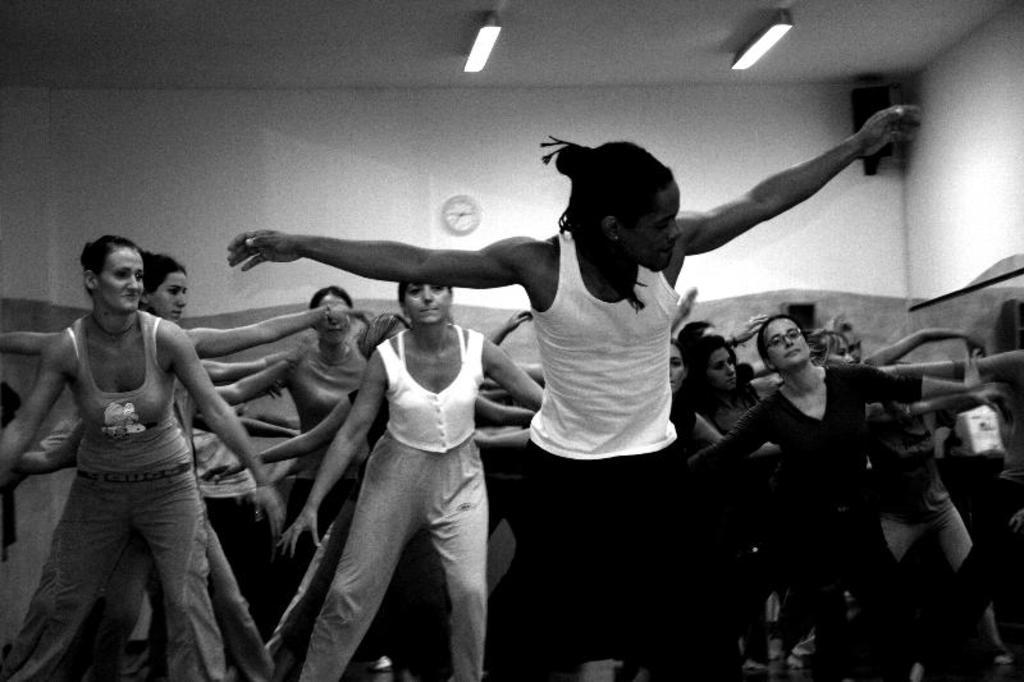What can be seen in the image involving a group of people? There is a group of people in the image. What is located at the top of the image? Lights, a clock, and a speaker are present at the top of the image. What is the color scheme of the image? The image is in black and white. How many strangers are present in the image? The term "stranger" is not mentioned in the facts provided, so it is not possible to determine the number of strangers in the image. 